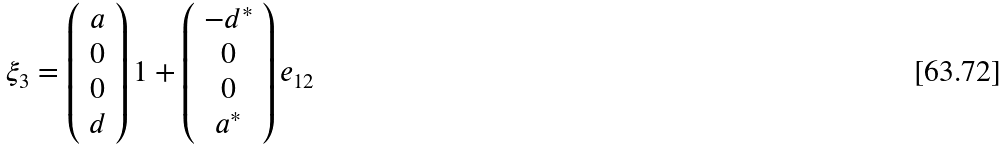Convert formula to latex. <formula><loc_0><loc_0><loc_500><loc_500>\xi _ { 3 } = \left ( \begin{array} { c } a \\ 0 \\ 0 \\ d \end{array} \right ) 1 + \left ( \begin{array} { c } - d ^ { * } \\ 0 \\ 0 \\ a ^ { * } \end{array} \right ) e _ { 1 2 }</formula> 